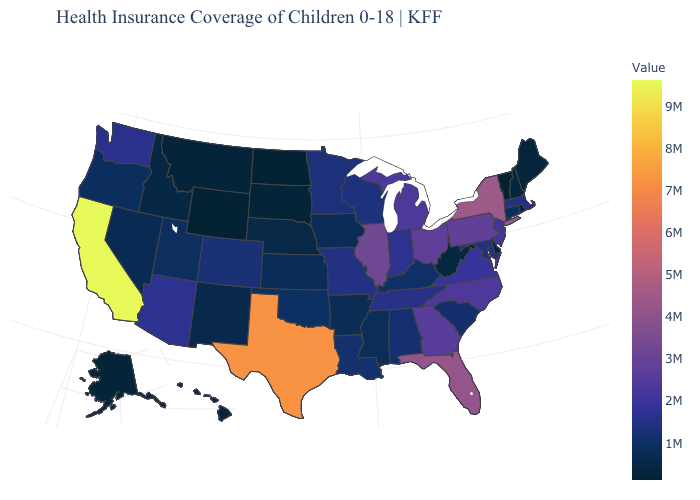Is the legend a continuous bar?
Short answer required. Yes. Which states have the lowest value in the USA?
Quick response, please. Vermont. Does Idaho have a higher value than Maryland?
Quick response, please. No. Does Pennsylvania have a lower value than Oregon?
Give a very brief answer. No. Which states have the lowest value in the South?
Write a very short answer. Delaware. Does the map have missing data?
Give a very brief answer. No. Does California have the highest value in the USA?
Short answer required. Yes. 